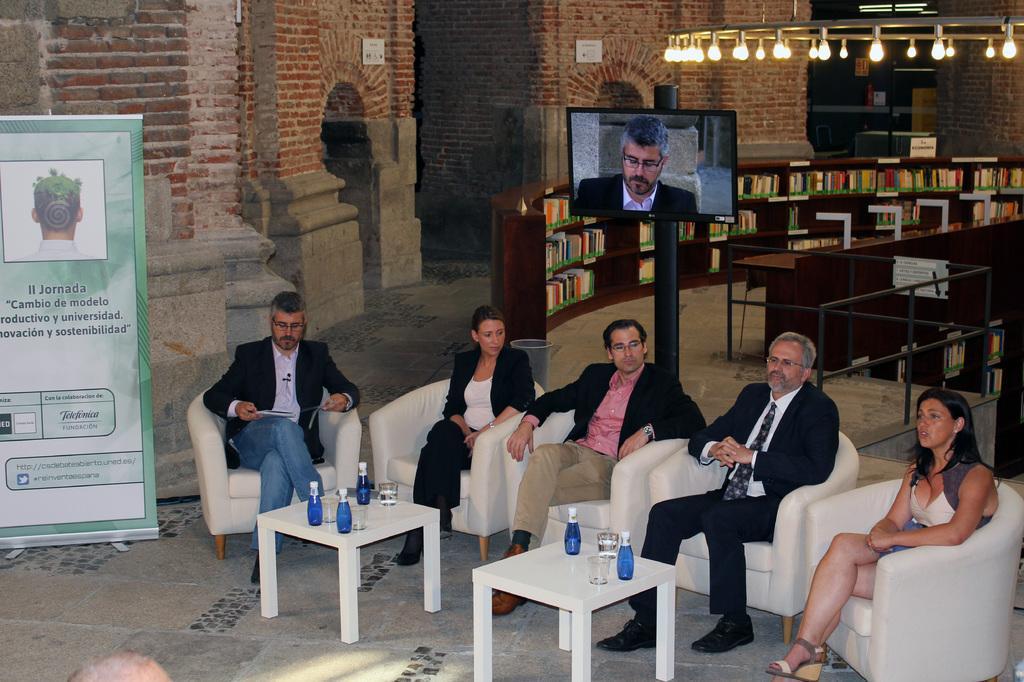In one or two sentences, can you explain what this image depicts? There are so many people sitting on chairs and table in front of them with bottles. behind them there is a pole and TV on it. At the back there is a bookshelves with books in it. 